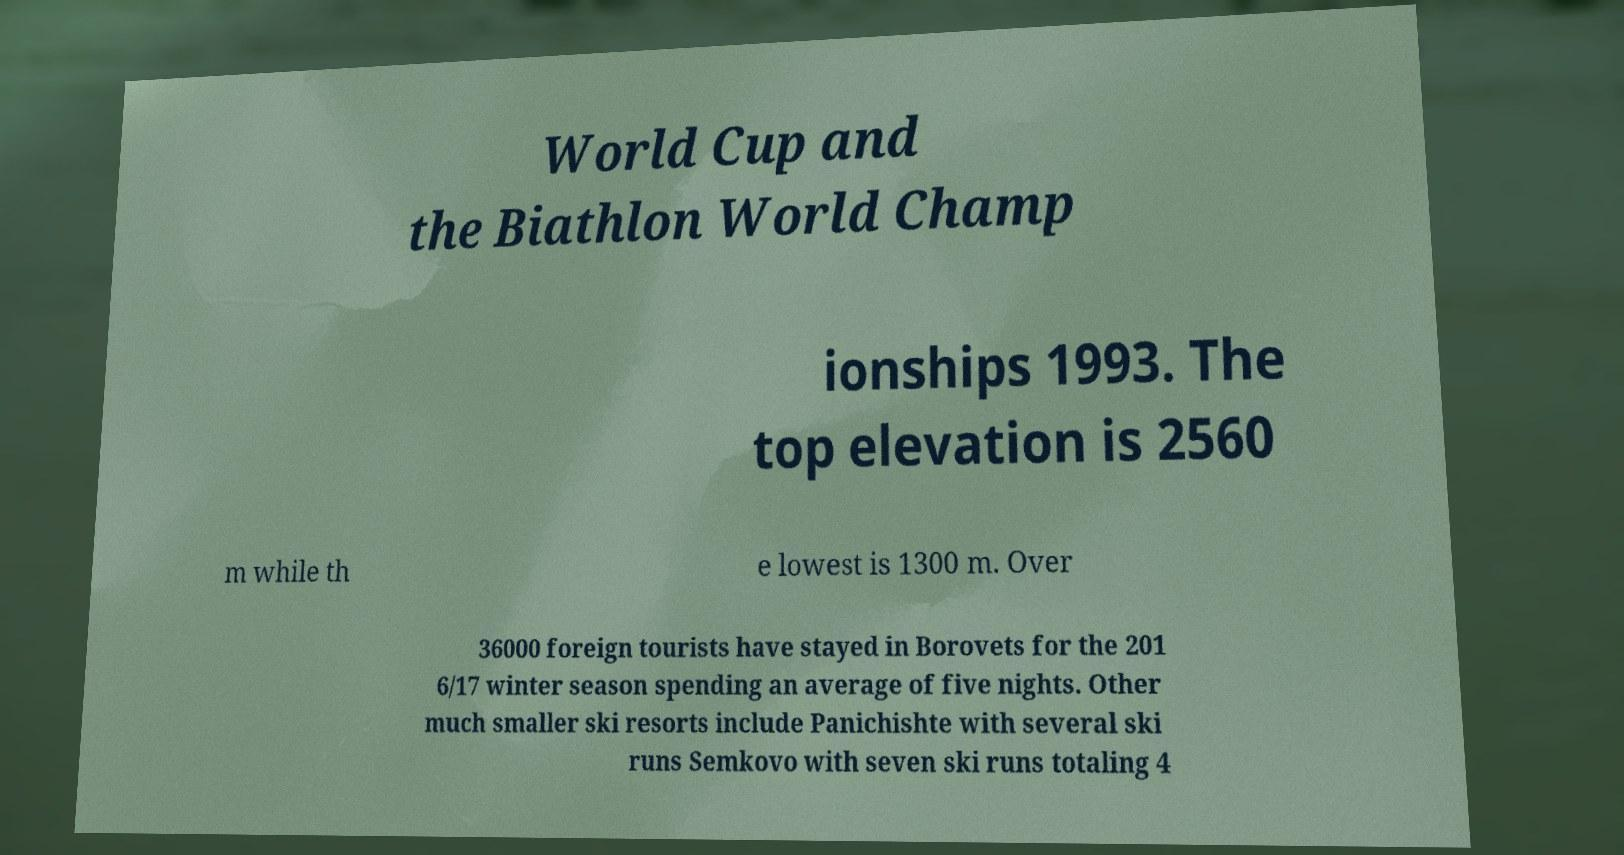There's text embedded in this image that I need extracted. Can you transcribe it verbatim? World Cup and the Biathlon World Champ ionships 1993. The top elevation is 2560 m while th e lowest is 1300 m. Over 36000 foreign tourists have stayed in Borovets for the 201 6/17 winter season spending an average of five nights. Other much smaller ski resorts include Panichishte with several ski runs Semkovo with seven ski runs totaling 4 